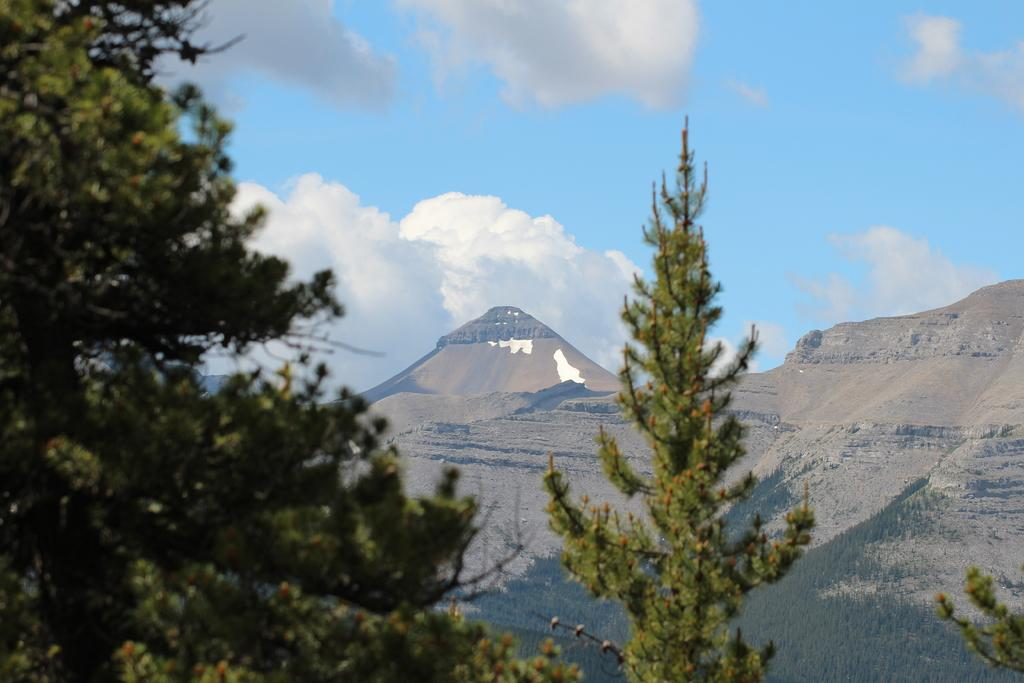What type of natural features can be seen in the image? There are trees and mountains in the image. What is the condition of the sky in the image? The sky is cloudy in the image. What type of representative can be seen shopping for a bag in the image? There is no representative or shopping activity present in the image; it features trees, mountains, and a cloudy sky. 